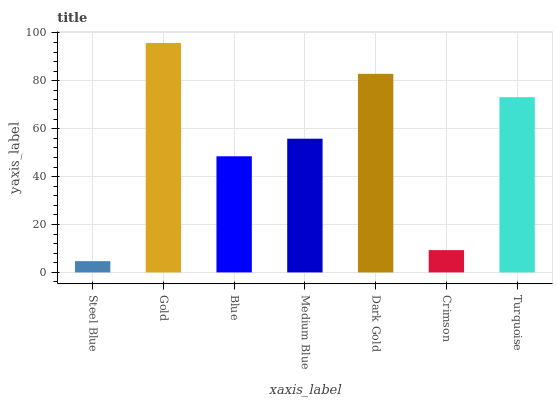Is Steel Blue the minimum?
Answer yes or no. Yes. Is Gold the maximum?
Answer yes or no. Yes. Is Blue the minimum?
Answer yes or no. No. Is Blue the maximum?
Answer yes or no. No. Is Gold greater than Blue?
Answer yes or no. Yes. Is Blue less than Gold?
Answer yes or no. Yes. Is Blue greater than Gold?
Answer yes or no. No. Is Gold less than Blue?
Answer yes or no. No. Is Medium Blue the high median?
Answer yes or no. Yes. Is Medium Blue the low median?
Answer yes or no. Yes. Is Crimson the high median?
Answer yes or no. No. Is Dark Gold the low median?
Answer yes or no. No. 